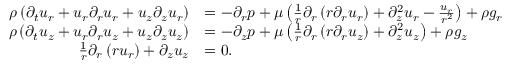<formula> <loc_0><loc_0><loc_500><loc_500>{ \begin{array} { r l } { \rho \left ( { \partial _ { t } u _ { r } } + u _ { r } { \partial _ { r } u _ { r } } + u _ { z } { \partial _ { z } u _ { r } } \right ) } & { = - { \partial _ { r } p } + \mu \left ( { \frac { 1 } { r } } \partial _ { r } \left ( r { \partial _ { r } u _ { r } } \right ) + { \partial _ { z } ^ { 2 } u _ { r } } - { \frac { u _ { r } } { r ^ { 2 } } } \right ) + \rho g _ { r } } \\ { \rho \left ( { \partial _ { t } u _ { z } } + u _ { r } { \partial _ { r } u _ { z } } + u _ { z } { \partial _ { z } u _ { z } } \right ) } & { = - { \partial _ { z } p } + \mu \left ( { \frac { 1 } { r } } \partial _ { r } \left ( r { \partial _ { r } u _ { z } } \right ) + { \partial _ { z } ^ { 2 } u _ { z } } \right ) + \rho g _ { z } } \\ { { \frac { 1 } { r } } \partial _ { r } \left ( r u _ { r } \right ) + { \partial _ { z } u _ { z } } } & { = 0 . } \end{array} }</formula> 